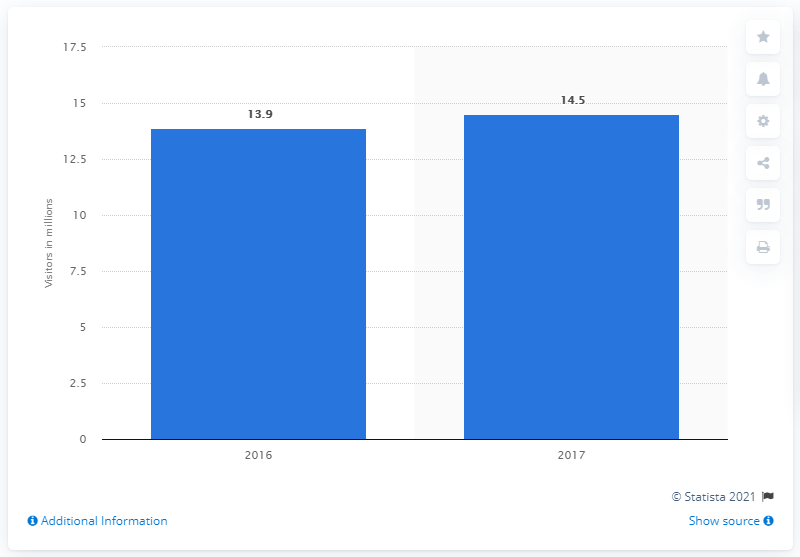List a handful of essential elements in this visual. In 2017, Nashville was visited by approximately 14.5 people. 